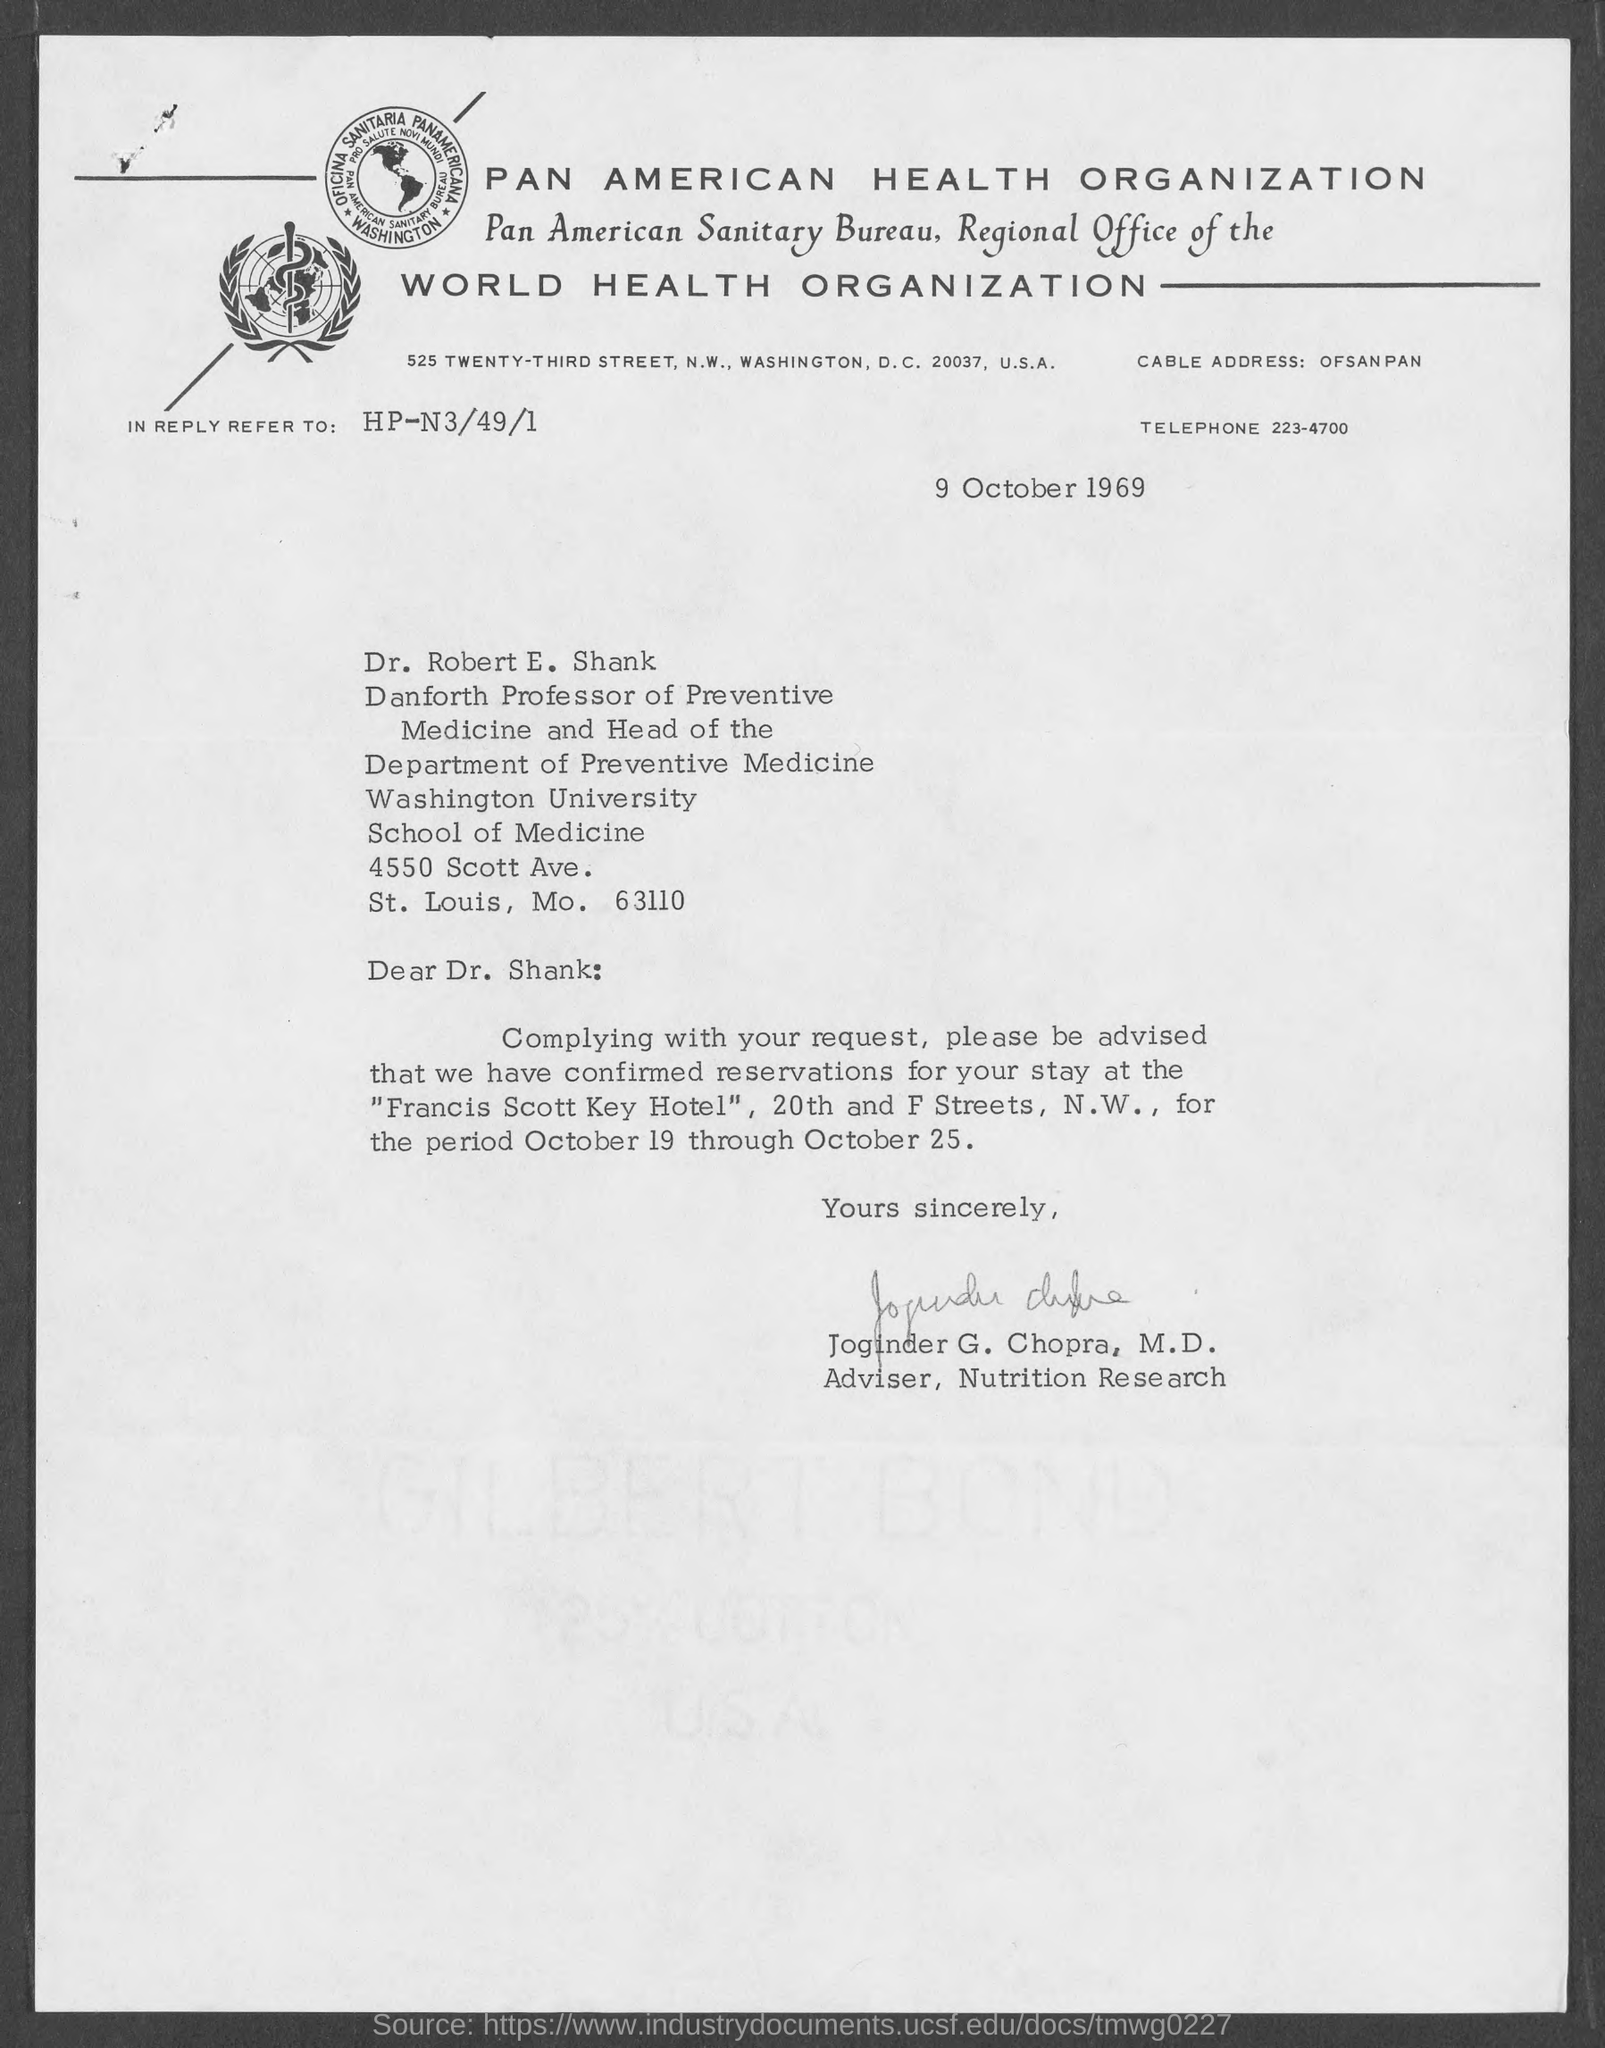To whom is this letter written to?
Your response must be concise. Dr. Robert E. Shank. Who wrote this letter?
Offer a terse response. Joginder G. Chopra. What is the position of joginder g. chopra m.d.?
Make the answer very short. Adviser, Nutrition Research. 